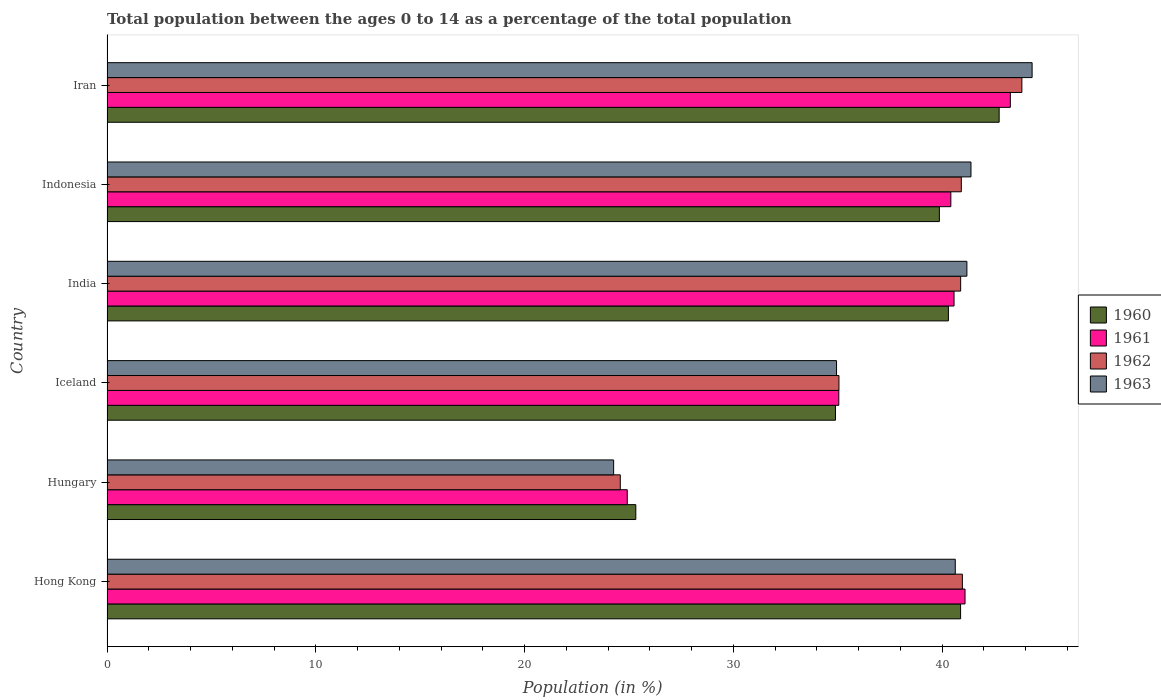How many different coloured bars are there?
Make the answer very short. 4. How many groups of bars are there?
Make the answer very short. 6. Are the number of bars per tick equal to the number of legend labels?
Make the answer very short. Yes. Are the number of bars on each tick of the Y-axis equal?
Offer a terse response. Yes. What is the percentage of the population ages 0 to 14 in 1961 in Iceland?
Your answer should be very brief. 35.05. Across all countries, what is the maximum percentage of the population ages 0 to 14 in 1962?
Offer a terse response. 43.82. Across all countries, what is the minimum percentage of the population ages 0 to 14 in 1963?
Your answer should be very brief. 24.27. In which country was the percentage of the population ages 0 to 14 in 1963 maximum?
Make the answer very short. Iran. In which country was the percentage of the population ages 0 to 14 in 1961 minimum?
Your answer should be very brief. Hungary. What is the total percentage of the population ages 0 to 14 in 1962 in the graph?
Ensure brevity in your answer.  226.24. What is the difference between the percentage of the population ages 0 to 14 in 1963 in Hong Kong and that in Iran?
Offer a very short reply. -3.68. What is the difference between the percentage of the population ages 0 to 14 in 1960 in Iran and the percentage of the population ages 0 to 14 in 1963 in Hong Kong?
Offer a terse response. 2.1. What is the average percentage of the population ages 0 to 14 in 1961 per country?
Offer a very short reply. 37.55. What is the difference between the percentage of the population ages 0 to 14 in 1961 and percentage of the population ages 0 to 14 in 1960 in India?
Make the answer very short. 0.27. What is the ratio of the percentage of the population ages 0 to 14 in 1963 in Hungary to that in India?
Make the answer very short. 0.59. What is the difference between the highest and the second highest percentage of the population ages 0 to 14 in 1962?
Keep it short and to the point. 2.85. What is the difference between the highest and the lowest percentage of the population ages 0 to 14 in 1961?
Keep it short and to the point. 18.35. In how many countries, is the percentage of the population ages 0 to 14 in 1962 greater than the average percentage of the population ages 0 to 14 in 1962 taken over all countries?
Your response must be concise. 4. Is it the case that in every country, the sum of the percentage of the population ages 0 to 14 in 1961 and percentage of the population ages 0 to 14 in 1963 is greater than the sum of percentage of the population ages 0 to 14 in 1960 and percentage of the population ages 0 to 14 in 1962?
Your response must be concise. No. Is it the case that in every country, the sum of the percentage of the population ages 0 to 14 in 1960 and percentage of the population ages 0 to 14 in 1963 is greater than the percentage of the population ages 0 to 14 in 1962?
Give a very brief answer. Yes. How many countries are there in the graph?
Your answer should be compact. 6. Are the values on the major ticks of X-axis written in scientific E-notation?
Ensure brevity in your answer.  No. Does the graph contain any zero values?
Offer a terse response. No. Where does the legend appear in the graph?
Your answer should be compact. Center right. What is the title of the graph?
Provide a succinct answer. Total population between the ages 0 to 14 as a percentage of the total population. Does "1972" appear as one of the legend labels in the graph?
Your answer should be compact. No. What is the label or title of the X-axis?
Provide a succinct answer. Population (in %). What is the label or title of the Y-axis?
Give a very brief answer. Country. What is the Population (in %) of 1960 in Hong Kong?
Keep it short and to the point. 40.89. What is the Population (in %) of 1961 in Hong Kong?
Your answer should be very brief. 41.1. What is the Population (in %) of 1962 in Hong Kong?
Your answer should be very brief. 40.97. What is the Population (in %) of 1963 in Hong Kong?
Make the answer very short. 40.63. What is the Population (in %) of 1960 in Hungary?
Give a very brief answer. 25.33. What is the Population (in %) of 1961 in Hungary?
Make the answer very short. 24.92. What is the Population (in %) in 1962 in Hungary?
Provide a succinct answer. 24.59. What is the Population (in %) of 1963 in Hungary?
Give a very brief answer. 24.27. What is the Population (in %) in 1960 in Iceland?
Offer a very short reply. 34.89. What is the Population (in %) in 1961 in Iceland?
Provide a short and direct response. 35.05. What is the Population (in %) of 1962 in Iceland?
Keep it short and to the point. 35.06. What is the Population (in %) of 1963 in Iceland?
Offer a very short reply. 34.94. What is the Population (in %) in 1960 in India?
Give a very brief answer. 40.3. What is the Population (in %) of 1961 in India?
Give a very brief answer. 40.57. What is the Population (in %) of 1962 in India?
Make the answer very short. 40.89. What is the Population (in %) in 1963 in India?
Your response must be concise. 41.19. What is the Population (in %) of 1960 in Indonesia?
Offer a very short reply. 39.87. What is the Population (in %) in 1961 in Indonesia?
Your answer should be very brief. 40.42. What is the Population (in %) of 1962 in Indonesia?
Make the answer very short. 40.92. What is the Population (in %) of 1963 in Indonesia?
Your answer should be very brief. 41.38. What is the Population (in %) of 1960 in Iran?
Make the answer very short. 42.73. What is the Population (in %) in 1961 in Iran?
Provide a short and direct response. 43.27. What is the Population (in %) of 1962 in Iran?
Make the answer very short. 43.82. What is the Population (in %) in 1963 in Iran?
Ensure brevity in your answer.  44.31. Across all countries, what is the maximum Population (in %) of 1960?
Offer a terse response. 42.73. Across all countries, what is the maximum Population (in %) of 1961?
Your answer should be compact. 43.27. Across all countries, what is the maximum Population (in %) in 1962?
Your answer should be compact. 43.82. Across all countries, what is the maximum Population (in %) of 1963?
Make the answer very short. 44.31. Across all countries, what is the minimum Population (in %) in 1960?
Give a very brief answer. 25.33. Across all countries, what is the minimum Population (in %) in 1961?
Keep it short and to the point. 24.92. Across all countries, what is the minimum Population (in %) in 1962?
Keep it short and to the point. 24.59. Across all countries, what is the minimum Population (in %) of 1963?
Give a very brief answer. 24.27. What is the total Population (in %) of 1960 in the graph?
Offer a terse response. 224.01. What is the total Population (in %) in 1961 in the graph?
Ensure brevity in your answer.  225.33. What is the total Population (in %) in 1962 in the graph?
Ensure brevity in your answer.  226.24. What is the total Population (in %) of 1963 in the graph?
Offer a very short reply. 226.72. What is the difference between the Population (in %) of 1960 in Hong Kong and that in Hungary?
Your answer should be very brief. 15.56. What is the difference between the Population (in %) in 1961 in Hong Kong and that in Hungary?
Provide a short and direct response. 16.18. What is the difference between the Population (in %) of 1962 in Hong Kong and that in Hungary?
Keep it short and to the point. 16.39. What is the difference between the Population (in %) of 1963 in Hong Kong and that in Hungary?
Make the answer very short. 16.36. What is the difference between the Population (in %) of 1960 in Hong Kong and that in Iceland?
Provide a short and direct response. 5.99. What is the difference between the Population (in %) in 1961 in Hong Kong and that in Iceland?
Your answer should be compact. 6.05. What is the difference between the Population (in %) in 1962 in Hong Kong and that in Iceland?
Offer a terse response. 5.91. What is the difference between the Population (in %) of 1963 in Hong Kong and that in Iceland?
Keep it short and to the point. 5.69. What is the difference between the Population (in %) in 1960 in Hong Kong and that in India?
Ensure brevity in your answer.  0.58. What is the difference between the Population (in %) in 1961 in Hong Kong and that in India?
Your answer should be compact. 0.53. What is the difference between the Population (in %) of 1962 in Hong Kong and that in India?
Keep it short and to the point. 0.08. What is the difference between the Population (in %) in 1963 in Hong Kong and that in India?
Your answer should be very brief. -0.56. What is the difference between the Population (in %) of 1960 in Hong Kong and that in Indonesia?
Ensure brevity in your answer.  1.02. What is the difference between the Population (in %) of 1961 in Hong Kong and that in Indonesia?
Keep it short and to the point. 0.68. What is the difference between the Population (in %) of 1962 in Hong Kong and that in Indonesia?
Offer a very short reply. 0.05. What is the difference between the Population (in %) in 1963 in Hong Kong and that in Indonesia?
Make the answer very short. -0.75. What is the difference between the Population (in %) in 1960 in Hong Kong and that in Iran?
Offer a very short reply. -1.85. What is the difference between the Population (in %) in 1961 in Hong Kong and that in Iran?
Your answer should be compact. -2.17. What is the difference between the Population (in %) of 1962 in Hong Kong and that in Iran?
Ensure brevity in your answer.  -2.85. What is the difference between the Population (in %) of 1963 in Hong Kong and that in Iran?
Offer a very short reply. -3.68. What is the difference between the Population (in %) in 1960 in Hungary and that in Iceland?
Offer a terse response. -9.56. What is the difference between the Population (in %) of 1961 in Hungary and that in Iceland?
Provide a short and direct response. -10.13. What is the difference between the Population (in %) of 1962 in Hungary and that in Iceland?
Offer a terse response. -10.47. What is the difference between the Population (in %) of 1963 in Hungary and that in Iceland?
Your answer should be very brief. -10.68. What is the difference between the Population (in %) in 1960 in Hungary and that in India?
Your response must be concise. -14.97. What is the difference between the Population (in %) of 1961 in Hungary and that in India?
Keep it short and to the point. -15.65. What is the difference between the Population (in %) in 1962 in Hungary and that in India?
Make the answer very short. -16.3. What is the difference between the Population (in %) of 1963 in Hungary and that in India?
Ensure brevity in your answer.  -16.92. What is the difference between the Population (in %) in 1960 in Hungary and that in Indonesia?
Provide a short and direct response. -14.54. What is the difference between the Population (in %) in 1961 in Hungary and that in Indonesia?
Offer a very short reply. -15.5. What is the difference between the Population (in %) in 1962 in Hungary and that in Indonesia?
Offer a very short reply. -16.33. What is the difference between the Population (in %) of 1963 in Hungary and that in Indonesia?
Your answer should be very brief. -17.12. What is the difference between the Population (in %) in 1960 in Hungary and that in Iran?
Make the answer very short. -17.4. What is the difference between the Population (in %) in 1961 in Hungary and that in Iran?
Offer a very short reply. -18.35. What is the difference between the Population (in %) of 1962 in Hungary and that in Iran?
Provide a succinct answer. -19.24. What is the difference between the Population (in %) of 1963 in Hungary and that in Iran?
Your response must be concise. -20.04. What is the difference between the Population (in %) in 1960 in Iceland and that in India?
Make the answer very short. -5.41. What is the difference between the Population (in %) in 1961 in Iceland and that in India?
Provide a short and direct response. -5.52. What is the difference between the Population (in %) of 1962 in Iceland and that in India?
Keep it short and to the point. -5.83. What is the difference between the Population (in %) in 1963 in Iceland and that in India?
Make the answer very short. -6.24. What is the difference between the Population (in %) in 1960 in Iceland and that in Indonesia?
Make the answer very short. -4.98. What is the difference between the Population (in %) in 1961 in Iceland and that in Indonesia?
Offer a very short reply. -5.37. What is the difference between the Population (in %) in 1962 in Iceland and that in Indonesia?
Keep it short and to the point. -5.86. What is the difference between the Population (in %) of 1963 in Iceland and that in Indonesia?
Make the answer very short. -6.44. What is the difference between the Population (in %) of 1960 in Iceland and that in Iran?
Ensure brevity in your answer.  -7.84. What is the difference between the Population (in %) in 1961 in Iceland and that in Iran?
Your answer should be very brief. -8.22. What is the difference between the Population (in %) of 1962 in Iceland and that in Iran?
Your answer should be very brief. -8.76. What is the difference between the Population (in %) in 1963 in Iceland and that in Iran?
Your response must be concise. -9.37. What is the difference between the Population (in %) of 1960 in India and that in Indonesia?
Your response must be concise. 0.43. What is the difference between the Population (in %) of 1961 in India and that in Indonesia?
Your answer should be very brief. 0.15. What is the difference between the Population (in %) in 1962 in India and that in Indonesia?
Your answer should be compact. -0.03. What is the difference between the Population (in %) in 1963 in India and that in Indonesia?
Offer a very short reply. -0.2. What is the difference between the Population (in %) of 1960 in India and that in Iran?
Make the answer very short. -2.43. What is the difference between the Population (in %) of 1961 in India and that in Iran?
Your response must be concise. -2.7. What is the difference between the Population (in %) of 1962 in India and that in Iran?
Provide a succinct answer. -2.93. What is the difference between the Population (in %) of 1963 in India and that in Iran?
Ensure brevity in your answer.  -3.12. What is the difference between the Population (in %) of 1960 in Indonesia and that in Iran?
Offer a terse response. -2.86. What is the difference between the Population (in %) of 1961 in Indonesia and that in Iran?
Your answer should be compact. -2.85. What is the difference between the Population (in %) of 1962 in Indonesia and that in Iran?
Make the answer very short. -2.9. What is the difference between the Population (in %) in 1963 in Indonesia and that in Iran?
Make the answer very short. -2.93. What is the difference between the Population (in %) of 1960 in Hong Kong and the Population (in %) of 1961 in Hungary?
Provide a succinct answer. 15.97. What is the difference between the Population (in %) in 1960 in Hong Kong and the Population (in %) in 1962 in Hungary?
Make the answer very short. 16.3. What is the difference between the Population (in %) in 1960 in Hong Kong and the Population (in %) in 1963 in Hungary?
Provide a succinct answer. 16.62. What is the difference between the Population (in %) in 1961 in Hong Kong and the Population (in %) in 1962 in Hungary?
Provide a succinct answer. 16.51. What is the difference between the Population (in %) of 1961 in Hong Kong and the Population (in %) of 1963 in Hungary?
Provide a short and direct response. 16.83. What is the difference between the Population (in %) of 1962 in Hong Kong and the Population (in %) of 1963 in Hungary?
Keep it short and to the point. 16.7. What is the difference between the Population (in %) of 1960 in Hong Kong and the Population (in %) of 1961 in Iceland?
Offer a very short reply. 5.83. What is the difference between the Population (in %) of 1960 in Hong Kong and the Population (in %) of 1962 in Iceland?
Your answer should be very brief. 5.83. What is the difference between the Population (in %) in 1960 in Hong Kong and the Population (in %) in 1963 in Iceland?
Your answer should be very brief. 5.94. What is the difference between the Population (in %) in 1961 in Hong Kong and the Population (in %) in 1962 in Iceland?
Give a very brief answer. 6.04. What is the difference between the Population (in %) of 1961 in Hong Kong and the Population (in %) of 1963 in Iceland?
Keep it short and to the point. 6.15. What is the difference between the Population (in %) of 1962 in Hong Kong and the Population (in %) of 1963 in Iceland?
Provide a short and direct response. 6.03. What is the difference between the Population (in %) of 1960 in Hong Kong and the Population (in %) of 1961 in India?
Provide a short and direct response. 0.31. What is the difference between the Population (in %) in 1960 in Hong Kong and the Population (in %) in 1962 in India?
Provide a succinct answer. -0. What is the difference between the Population (in %) of 1960 in Hong Kong and the Population (in %) of 1963 in India?
Make the answer very short. -0.3. What is the difference between the Population (in %) of 1961 in Hong Kong and the Population (in %) of 1962 in India?
Give a very brief answer. 0.21. What is the difference between the Population (in %) of 1961 in Hong Kong and the Population (in %) of 1963 in India?
Keep it short and to the point. -0.09. What is the difference between the Population (in %) in 1962 in Hong Kong and the Population (in %) in 1963 in India?
Provide a succinct answer. -0.22. What is the difference between the Population (in %) in 1960 in Hong Kong and the Population (in %) in 1961 in Indonesia?
Ensure brevity in your answer.  0.47. What is the difference between the Population (in %) in 1960 in Hong Kong and the Population (in %) in 1962 in Indonesia?
Provide a short and direct response. -0.03. What is the difference between the Population (in %) in 1960 in Hong Kong and the Population (in %) in 1963 in Indonesia?
Make the answer very short. -0.5. What is the difference between the Population (in %) of 1961 in Hong Kong and the Population (in %) of 1962 in Indonesia?
Give a very brief answer. 0.18. What is the difference between the Population (in %) of 1961 in Hong Kong and the Population (in %) of 1963 in Indonesia?
Offer a terse response. -0.28. What is the difference between the Population (in %) of 1962 in Hong Kong and the Population (in %) of 1963 in Indonesia?
Offer a very short reply. -0.41. What is the difference between the Population (in %) in 1960 in Hong Kong and the Population (in %) in 1961 in Iran?
Your answer should be compact. -2.38. What is the difference between the Population (in %) of 1960 in Hong Kong and the Population (in %) of 1962 in Iran?
Keep it short and to the point. -2.94. What is the difference between the Population (in %) of 1960 in Hong Kong and the Population (in %) of 1963 in Iran?
Your answer should be very brief. -3.43. What is the difference between the Population (in %) in 1961 in Hong Kong and the Population (in %) in 1962 in Iran?
Your response must be concise. -2.72. What is the difference between the Population (in %) of 1961 in Hong Kong and the Population (in %) of 1963 in Iran?
Provide a short and direct response. -3.21. What is the difference between the Population (in %) in 1962 in Hong Kong and the Population (in %) in 1963 in Iran?
Make the answer very short. -3.34. What is the difference between the Population (in %) of 1960 in Hungary and the Population (in %) of 1961 in Iceland?
Offer a very short reply. -9.72. What is the difference between the Population (in %) of 1960 in Hungary and the Population (in %) of 1962 in Iceland?
Ensure brevity in your answer.  -9.73. What is the difference between the Population (in %) of 1960 in Hungary and the Population (in %) of 1963 in Iceland?
Your response must be concise. -9.61. What is the difference between the Population (in %) of 1961 in Hungary and the Population (in %) of 1962 in Iceland?
Your answer should be compact. -10.14. What is the difference between the Population (in %) in 1961 in Hungary and the Population (in %) in 1963 in Iceland?
Make the answer very short. -10.02. What is the difference between the Population (in %) of 1962 in Hungary and the Population (in %) of 1963 in Iceland?
Make the answer very short. -10.36. What is the difference between the Population (in %) in 1960 in Hungary and the Population (in %) in 1961 in India?
Your answer should be compact. -15.24. What is the difference between the Population (in %) of 1960 in Hungary and the Population (in %) of 1962 in India?
Offer a very short reply. -15.56. What is the difference between the Population (in %) of 1960 in Hungary and the Population (in %) of 1963 in India?
Offer a very short reply. -15.86. What is the difference between the Population (in %) in 1961 in Hungary and the Population (in %) in 1962 in India?
Provide a short and direct response. -15.97. What is the difference between the Population (in %) of 1961 in Hungary and the Population (in %) of 1963 in India?
Provide a succinct answer. -16.27. What is the difference between the Population (in %) of 1962 in Hungary and the Population (in %) of 1963 in India?
Your answer should be compact. -16.6. What is the difference between the Population (in %) in 1960 in Hungary and the Population (in %) in 1961 in Indonesia?
Make the answer very short. -15.09. What is the difference between the Population (in %) in 1960 in Hungary and the Population (in %) in 1962 in Indonesia?
Provide a succinct answer. -15.59. What is the difference between the Population (in %) of 1960 in Hungary and the Population (in %) of 1963 in Indonesia?
Offer a terse response. -16.05. What is the difference between the Population (in %) in 1961 in Hungary and the Population (in %) in 1962 in Indonesia?
Provide a short and direct response. -16. What is the difference between the Population (in %) in 1961 in Hungary and the Population (in %) in 1963 in Indonesia?
Provide a succinct answer. -16.46. What is the difference between the Population (in %) in 1962 in Hungary and the Population (in %) in 1963 in Indonesia?
Give a very brief answer. -16.8. What is the difference between the Population (in %) in 1960 in Hungary and the Population (in %) in 1961 in Iran?
Give a very brief answer. -17.94. What is the difference between the Population (in %) in 1960 in Hungary and the Population (in %) in 1962 in Iran?
Make the answer very short. -18.49. What is the difference between the Population (in %) in 1960 in Hungary and the Population (in %) in 1963 in Iran?
Ensure brevity in your answer.  -18.98. What is the difference between the Population (in %) of 1961 in Hungary and the Population (in %) of 1962 in Iran?
Offer a terse response. -18.9. What is the difference between the Population (in %) of 1961 in Hungary and the Population (in %) of 1963 in Iran?
Offer a very short reply. -19.39. What is the difference between the Population (in %) in 1962 in Hungary and the Population (in %) in 1963 in Iran?
Give a very brief answer. -19.73. What is the difference between the Population (in %) of 1960 in Iceland and the Population (in %) of 1961 in India?
Your answer should be very brief. -5.68. What is the difference between the Population (in %) in 1960 in Iceland and the Population (in %) in 1962 in India?
Offer a very short reply. -6. What is the difference between the Population (in %) in 1960 in Iceland and the Population (in %) in 1963 in India?
Offer a terse response. -6.29. What is the difference between the Population (in %) in 1961 in Iceland and the Population (in %) in 1962 in India?
Offer a terse response. -5.84. What is the difference between the Population (in %) in 1961 in Iceland and the Population (in %) in 1963 in India?
Make the answer very short. -6.14. What is the difference between the Population (in %) in 1962 in Iceland and the Population (in %) in 1963 in India?
Give a very brief answer. -6.13. What is the difference between the Population (in %) of 1960 in Iceland and the Population (in %) of 1961 in Indonesia?
Provide a short and direct response. -5.53. What is the difference between the Population (in %) in 1960 in Iceland and the Population (in %) in 1962 in Indonesia?
Provide a succinct answer. -6.03. What is the difference between the Population (in %) in 1960 in Iceland and the Population (in %) in 1963 in Indonesia?
Your answer should be very brief. -6.49. What is the difference between the Population (in %) of 1961 in Iceland and the Population (in %) of 1962 in Indonesia?
Keep it short and to the point. -5.87. What is the difference between the Population (in %) of 1961 in Iceland and the Population (in %) of 1963 in Indonesia?
Keep it short and to the point. -6.33. What is the difference between the Population (in %) in 1962 in Iceland and the Population (in %) in 1963 in Indonesia?
Your answer should be compact. -6.32. What is the difference between the Population (in %) of 1960 in Iceland and the Population (in %) of 1961 in Iran?
Offer a very short reply. -8.38. What is the difference between the Population (in %) in 1960 in Iceland and the Population (in %) in 1962 in Iran?
Keep it short and to the point. -8.93. What is the difference between the Population (in %) of 1960 in Iceland and the Population (in %) of 1963 in Iran?
Ensure brevity in your answer.  -9.42. What is the difference between the Population (in %) in 1961 in Iceland and the Population (in %) in 1962 in Iran?
Your answer should be compact. -8.77. What is the difference between the Population (in %) in 1961 in Iceland and the Population (in %) in 1963 in Iran?
Give a very brief answer. -9.26. What is the difference between the Population (in %) of 1962 in Iceland and the Population (in %) of 1963 in Iran?
Your answer should be very brief. -9.25. What is the difference between the Population (in %) in 1960 in India and the Population (in %) in 1961 in Indonesia?
Provide a short and direct response. -0.12. What is the difference between the Population (in %) in 1960 in India and the Population (in %) in 1962 in Indonesia?
Your answer should be compact. -0.62. What is the difference between the Population (in %) of 1960 in India and the Population (in %) of 1963 in Indonesia?
Offer a terse response. -1.08. What is the difference between the Population (in %) of 1961 in India and the Population (in %) of 1962 in Indonesia?
Ensure brevity in your answer.  -0.35. What is the difference between the Population (in %) of 1961 in India and the Population (in %) of 1963 in Indonesia?
Your response must be concise. -0.81. What is the difference between the Population (in %) of 1962 in India and the Population (in %) of 1963 in Indonesia?
Make the answer very short. -0.49. What is the difference between the Population (in %) of 1960 in India and the Population (in %) of 1961 in Iran?
Your answer should be compact. -2.97. What is the difference between the Population (in %) of 1960 in India and the Population (in %) of 1962 in Iran?
Your response must be concise. -3.52. What is the difference between the Population (in %) of 1960 in India and the Population (in %) of 1963 in Iran?
Keep it short and to the point. -4.01. What is the difference between the Population (in %) of 1961 in India and the Population (in %) of 1962 in Iran?
Offer a terse response. -3.25. What is the difference between the Population (in %) in 1961 in India and the Population (in %) in 1963 in Iran?
Your response must be concise. -3.74. What is the difference between the Population (in %) of 1962 in India and the Population (in %) of 1963 in Iran?
Provide a short and direct response. -3.42. What is the difference between the Population (in %) in 1960 in Indonesia and the Population (in %) in 1961 in Iran?
Provide a short and direct response. -3.4. What is the difference between the Population (in %) of 1960 in Indonesia and the Population (in %) of 1962 in Iran?
Provide a succinct answer. -3.95. What is the difference between the Population (in %) of 1960 in Indonesia and the Population (in %) of 1963 in Iran?
Offer a very short reply. -4.44. What is the difference between the Population (in %) of 1961 in Indonesia and the Population (in %) of 1962 in Iran?
Provide a short and direct response. -3.4. What is the difference between the Population (in %) of 1961 in Indonesia and the Population (in %) of 1963 in Iran?
Offer a very short reply. -3.89. What is the difference between the Population (in %) in 1962 in Indonesia and the Population (in %) in 1963 in Iran?
Make the answer very short. -3.39. What is the average Population (in %) of 1960 per country?
Make the answer very short. 37.33. What is the average Population (in %) in 1961 per country?
Offer a very short reply. 37.55. What is the average Population (in %) of 1962 per country?
Offer a very short reply. 37.71. What is the average Population (in %) of 1963 per country?
Provide a succinct answer. 37.79. What is the difference between the Population (in %) of 1960 and Population (in %) of 1961 in Hong Kong?
Give a very brief answer. -0.21. What is the difference between the Population (in %) of 1960 and Population (in %) of 1962 in Hong Kong?
Offer a terse response. -0.09. What is the difference between the Population (in %) of 1960 and Population (in %) of 1963 in Hong Kong?
Your answer should be very brief. 0.25. What is the difference between the Population (in %) of 1961 and Population (in %) of 1962 in Hong Kong?
Ensure brevity in your answer.  0.13. What is the difference between the Population (in %) of 1961 and Population (in %) of 1963 in Hong Kong?
Your answer should be compact. 0.47. What is the difference between the Population (in %) in 1962 and Population (in %) in 1963 in Hong Kong?
Your response must be concise. 0.34. What is the difference between the Population (in %) of 1960 and Population (in %) of 1961 in Hungary?
Provide a short and direct response. 0.41. What is the difference between the Population (in %) of 1960 and Population (in %) of 1962 in Hungary?
Provide a succinct answer. 0.74. What is the difference between the Population (in %) in 1960 and Population (in %) in 1963 in Hungary?
Give a very brief answer. 1.06. What is the difference between the Population (in %) in 1961 and Population (in %) in 1962 in Hungary?
Offer a very short reply. 0.33. What is the difference between the Population (in %) in 1961 and Population (in %) in 1963 in Hungary?
Provide a short and direct response. 0.65. What is the difference between the Population (in %) in 1962 and Population (in %) in 1963 in Hungary?
Offer a very short reply. 0.32. What is the difference between the Population (in %) of 1960 and Population (in %) of 1961 in Iceland?
Give a very brief answer. -0.16. What is the difference between the Population (in %) of 1960 and Population (in %) of 1962 in Iceland?
Your answer should be very brief. -0.17. What is the difference between the Population (in %) of 1960 and Population (in %) of 1963 in Iceland?
Ensure brevity in your answer.  -0.05. What is the difference between the Population (in %) of 1961 and Population (in %) of 1962 in Iceland?
Provide a short and direct response. -0.01. What is the difference between the Population (in %) of 1961 and Population (in %) of 1963 in Iceland?
Give a very brief answer. 0.11. What is the difference between the Population (in %) in 1962 and Population (in %) in 1963 in Iceland?
Offer a terse response. 0.12. What is the difference between the Population (in %) in 1960 and Population (in %) in 1961 in India?
Your answer should be compact. -0.27. What is the difference between the Population (in %) in 1960 and Population (in %) in 1962 in India?
Give a very brief answer. -0.59. What is the difference between the Population (in %) in 1960 and Population (in %) in 1963 in India?
Provide a succinct answer. -0.89. What is the difference between the Population (in %) in 1961 and Population (in %) in 1962 in India?
Provide a short and direct response. -0.32. What is the difference between the Population (in %) of 1961 and Population (in %) of 1963 in India?
Ensure brevity in your answer.  -0.62. What is the difference between the Population (in %) of 1962 and Population (in %) of 1963 in India?
Offer a terse response. -0.3. What is the difference between the Population (in %) of 1960 and Population (in %) of 1961 in Indonesia?
Your answer should be very brief. -0.55. What is the difference between the Population (in %) in 1960 and Population (in %) in 1962 in Indonesia?
Your answer should be compact. -1.05. What is the difference between the Population (in %) of 1960 and Population (in %) of 1963 in Indonesia?
Your answer should be compact. -1.51. What is the difference between the Population (in %) in 1961 and Population (in %) in 1962 in Indonesia?
Offer a very short reply. -0.5. What is the difference between the Population (in %) of 1961 and Population (in %) of 1963 in Indonesia?
Ensure brevity in your answer.  -0.96. What is the difference between the Population (in %) of 1962 and Population (in %) of 1963 in Indonesia?
Provide a succinct answer. -0.46. What is the difference between the Population (in %) of 1960 and Population (in %) of 1961 in Iran?
Offer a very short reply. -0.54. What is the difference between the Population (in %) of 1960 and Population (in %) of 1962 in Iran?
Provide a succinct answer. -1.09. What is the difference between the Population (in %) of 1960 and Population (in %) of 1963 in Iran?
Offer a very short reply. -1.58. What is the difference between the Population (in %) in 1961 and Population (in %) in 1962 in Iran?
Your answer should be compact. -0.55. What is the difference between the Population (in %) of 1961 and Population (in %) of 1963 in Iran?
Your response must be concise. -1.04. What is the difference between the Population (in %) in 1962 and Population (in %) in 1963 in Iran?
Your answer should be very brief. -0.49. What is the ratio of the Population (in %) of 1960 in Hong Kong to that in Hungary?
Offer a very short reply. 1.61. What is the ratio of the Population (in %) in 1961 in Hong Kong to that in Hungary?
Provide a short and direct response. 1.65. What is the ratio of the Population (in %) in 1962 in Hong Kong to that in Hungary?
Give a very brief answer. 1.67. What is the ratio of the Population (in %) of 1963 in Hong Kong to that in Hungary?
Keep it short and to the point. 1.67. What is the ratio of the Population (in %) in 1960 in Hong Kong to that in Iceland?
Your response must be concise. 1.17. What is the ratio of the Population (in %) of 1961 in Hong Kong to that in Iceland?
Keep it short and to the point. 1.17. What is the ratio of the Population (in %) of 1962 in Hong Kong to that in Iceland?
Keep it short and to the point. 1.17. What is the ratio of the Population (in %) in 1963 in Hong Kong to that in Iceland?
Your answer should be compact. 1.16. What is the ratio of the Population (in %) of 1960 in Hong Kong to that in India?
Make the answer very short. 1.01. What is the ratio of the Population (in %) of 1961 in Hong Kong to that in India?
Offer a terse response. 1.01. What is the ratio of the Population (in %) of 1963 in Hong Kong to that in India?
Your answer should be compact. 0.99. What is the ratio of the Population (in %) of 1960 in Hong Kong to that in Indonesia?
Keep it short and to the point. 1.03. What is the ratio of the Population (in %) of 1961 in Hong Kong to that in Indonesia?
Provide a short and direct response. 1.02. What is the ratio of the Population (in %) of 1962 in Hong Kong to that in Indonesia?
Ensure brevity in your answer.  1. What is the ratio of the Population (in %) of 1963 in Hong Kong to that in Indonesia?
Your answer should be very brief. 0.98. What is the ratio of the Population (in %) in 1960 in Hong Kong to that in Iran?
Offer a very short reply. 0.96. What is the ratio of the Population (in %) in 1961 in Hong Kong to that in Iran?
Provide a succinct answer. 0.95. What is the ratio of the Population (in %) in 1962 in Hong Kong to that in Iran?
Your answer should be compact. 0.94. What is the ratio of the Population (in %) of 1963 in Hong Kong to that in Iran?
Give a very brief answer. 0.92. What is the ratio of the Population (in %) in 1960 in Hungary to that in Iceland?
Keep it short and to the point. 0.73. What is the ratio of the Population (in %) in 1961 in Hungary to that in Iceland?
Provide a succinct answer. 0.71. What is the ratio of the Population (in %) of 1962 in Hungary to that in Iceland?
Ensure brevity in your answer.  0.7. What is the ratio of the Population (in %) in 1963 in Hungary to that in Iceland?
Provide a succinct answer. 0.69. What is the ratio of the Population (in %) in 1960 in Hungary to that in India?
Offer a very short reply. 0.63. What is the ratio of the Population (in %) in 1961 in Hungary to that in India?
Offer a very short reply. 0.61. What is the ratio of the Population (in %) in 1962 in Hungary to that in India?
Ensure brevity in your answer.  0.6. What is the ratio of the Population (in %) in 1963 in Hungary to that in India?
Provide a short and direct response. 0.59. What is the ratio of the Population (in %) in 1960 in Hungary to that in Indonesia?
Make the answer very short. 0.64. What is the ratio of the Population (in %) in 1961 in Hungary to that in Indonesia?
Provide a short and direct response. 0.62. What is the ratio of the Population (in %) of 1962 in Hungary to that in Indonesia?
Offer a terse response. 0.6. What is the ratio of the Population (in %) in 1963 in Hungary to that in Indonesia?
Give a very brief answer. 0.59. What is the ratio of the Population (in %) in 1960 in Hungary to that in Iran?
Give a very brief answer. 0.59. What is the ratio of the Population (in %) in 1961 in Hungary to that in Iran?
Your answer should be very brief. 0.58. What is the ratio of the Population (in %) of 1962 in Hungary to that in Iran?
Give a very brief answer. 0.56. What is the ratio of the Population (in %) in 1963 in Hungary to that in Iran?
Ensure brevity in your answer.  0.55. What is the ratio of the Population (in %) of 1960 in Iceland to that in India?
Ensure brevity in your answer.  0.87. What is the ratio of the Population (in %) in 1961 in Iceland to that in India?
Your response must be concise. 0.86. What is the ratio of the Population (in %) of 1962 in Iceland to that in India?
Your response must be concise. 0.86. What is the ratio of the Population (in %) of 1963 in Iceland to that in India?
Ensure brevity in your answer.  0.85. What is the ratio of the Population (in %) in 1960 in Iceland to that in Indonesia?
Your answer should be very brief. 0.88. What is the ratio of the Population (in %) in 1961 in Iceland to that in Indonesia?
Give a very brief answer. 0.87. What is the ratio of the Population (in %) in 1962 in Iceland to that in Indonesia?
Offer a very short reply. 0.86. What is the ratio of the Population (in %) in 1963 in Iceland to that in Indonesia?
Ensure brevity in your answer.  0.84. What is the ratio of the Population (in %) in 1960 in Iceland to that in Iran?
Ensure brevity in your answer.  0.82. What is the ratio of the Population (in %) of 1961 in Iceland to that in Iran?
Your response must be concise. 0.81. What is the ratio of the Population (in %) in 1962 in Iceland to that in Iran?
Provide a short and direct response. 0.8. What is the ratio of the Population (in %) in 1963 in Iceland to that in Iran?
Provide a short and direct response. 0.79. What is the ratio of the Population (in %) in 1960 in India to that in Indonesia?
Ensure brevity in your answer.  1.01. What is the ratio of the Population (in %) in 1963 in India to that in Indonesia?
Make the answer very short. 1. What is the ratio of the Population (in %) in 1960 in India to that in Iran?
Offer a very short reply. 0.94. What is the ratio of the Population (in %) in 1961 in India to that in Iran?
Ensure brevity in your answer.  0.94. What is the ratio of the Population (in %) of 1962 in India to that in Iran?
Your answer should be compact. 0.93. What is the ratio of the Population (in %) in 1963 in India to that in Iran?
Your response must be concise. 0.93. What is the ratio of the Population (in %) of 1960 in Indonesia to that in Iran?
Make the answer very short. 0.93. What is the ratio of the Population (in %) in 1961 in Indonesia to that in Iran?
Offer a terse response. 0.93. What is the ratio of the Population (in %) in 1962 in Indonesia to that in Iran?
Provide a short and direct response. 0.93. What is the ratio of the Population (in %) in 1963 in Indonesia to that in Iran?
Provide a succinct answer. 0.93. What is the difference between the highest and the second highest Population (in %) in 1960?
Keep it short and to the point. 1.85. What is the difference between the highest and the second highest Population (in %) in 1961?
Keep it short and to the point. 2.17. What is the difference between the highest and the second highest Population (in %) in 1962?
Offer a very short reply. 2.85. What is the difference between the highest and the second highest Population (in %) in 1963?
Your answer should be compact. 2.93. What is the difference between the highest and the lowest Population (in %) in 1960?
Offer a terse response. 17.4. What is the difference between the highest and the lowest Population (in %) of 1961?
Make the answer very short. 18.35. What is the difference between the highest and the lowest Population (in %) of 1962?
Provide a short and direct response. 19.24. What is the difference between the highest and the lowest Population (in %) in 1963?
Your answer should be compact. 20.04. 